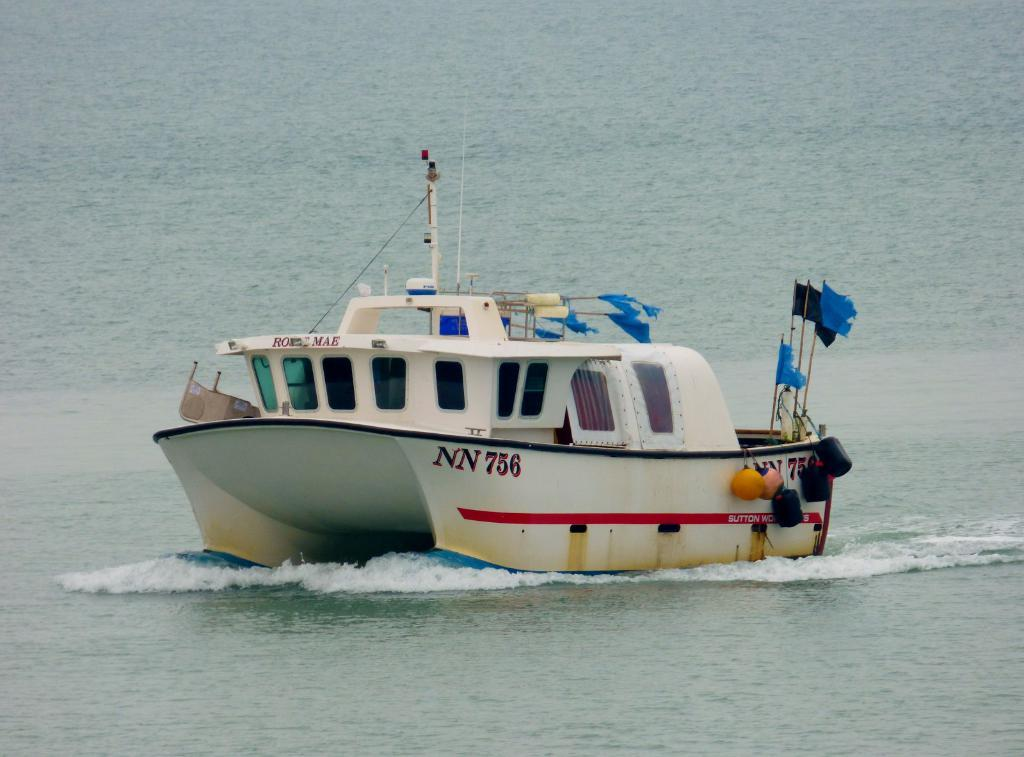What is the main subject of the image? The main subject of the image is a boat. Where is the boat located? The boat is on the surface of water. Are there any additional features on the boat? Yes, there are flags visible on the boat. What else can be seen on the boat? There are objects on the boat. How does the boat aid in the digestion process of the fish in the image? There are no fish present in the image, and the boat does not have any role in the digestion process. 